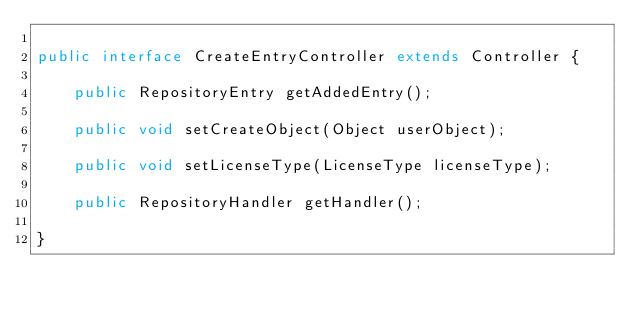<code> <loc_0><loc_0><loc_500><loc_500><_Java_>
public interface CreateEntryController extends Controller {
	
	public RepositoryEntry getAddedEntry();
	
	public void setCreateObject(Object userObject);
	
	public void setLicenseType(LicenseType licenseType);
	
	public RepositoryHandler getHandler();
	
}
</code> 